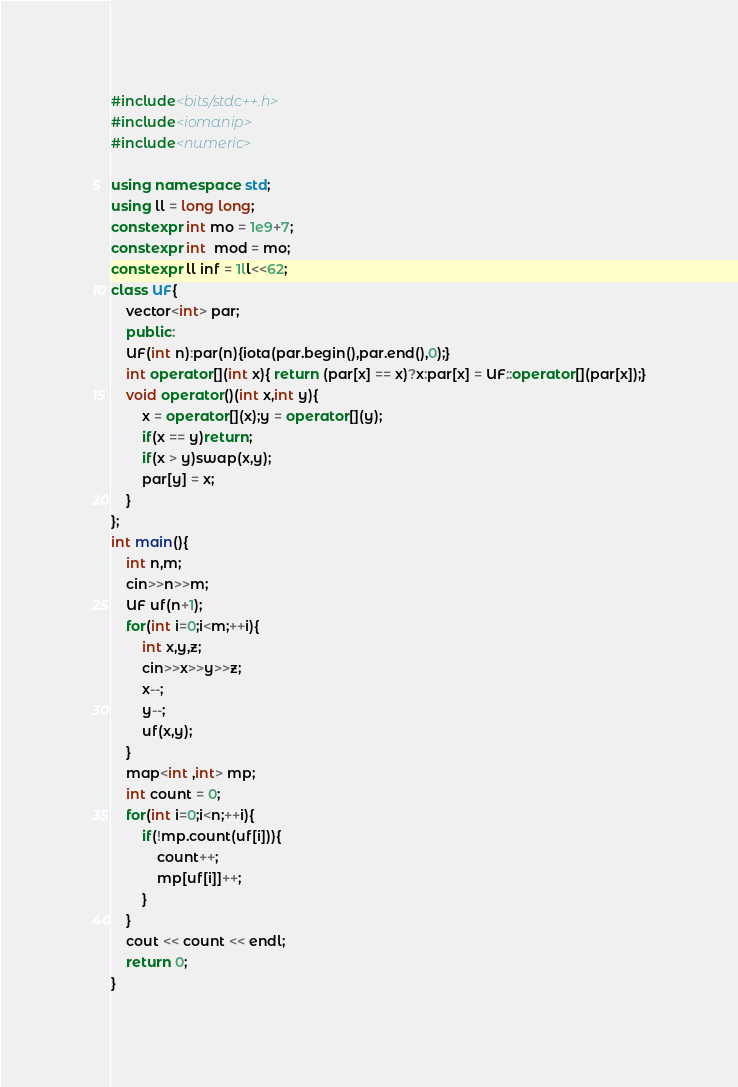<code> <loc_0><loc_0><loc_500><loc_500><_C++_>#include<bits/stdc++.h>
#include<iomanip>
#include<numeric>

using namespace std;
using ll = long long;
constexpr int mo = 1e9+7;
constexpr int  mod = mo;
constexpr ll inf = 1ll<<62;
class UF{
    vector<int> par;
    public:
    UF(int n):par(n){iota(par.begin(),par.end(),0);}
    int operator[](int x){ return (par[x] == x)?x:par[x] = UF::operator[](par[x]);}
    void operator()(int x,int y){
        x = operator[](x);y = operator[](y);
        if(x == y)return;
        if(x > y)swap(x,y);
        par[y] = x;
    }
};
int main(){
    int n,m;
    cin>>n>>m;
    UF uf(n+1);
    for(int i=0;i<m;++i){
        int x,y,z;
        cin>>x>>y>>z;
        x--;
        y--;
        uf(x,y);
    }
    map<int ,int> mp;
    int count = 0;
    for(int i=0;i<n;++i){
        if(!mp.count(uf[i])){
            count++;
            mp[uf[i]]++;
        }
    }
    cout << count << endl;
    return 0;
}

</code> 